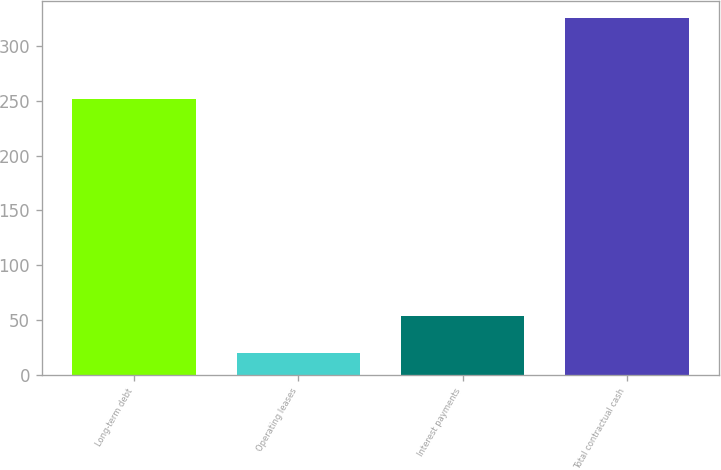Convert chart to OTSL. <chart><loc_0><loc_0><loc_500><loc_500><bar_chart><fcel>Long-term debt<fcel>Operating leases<fcel>Interest payments<fcel>Total contractual cash<nl><fcel>251.5<fcel>19.8<fcel>53.7<fcel>325<nl></chart> 